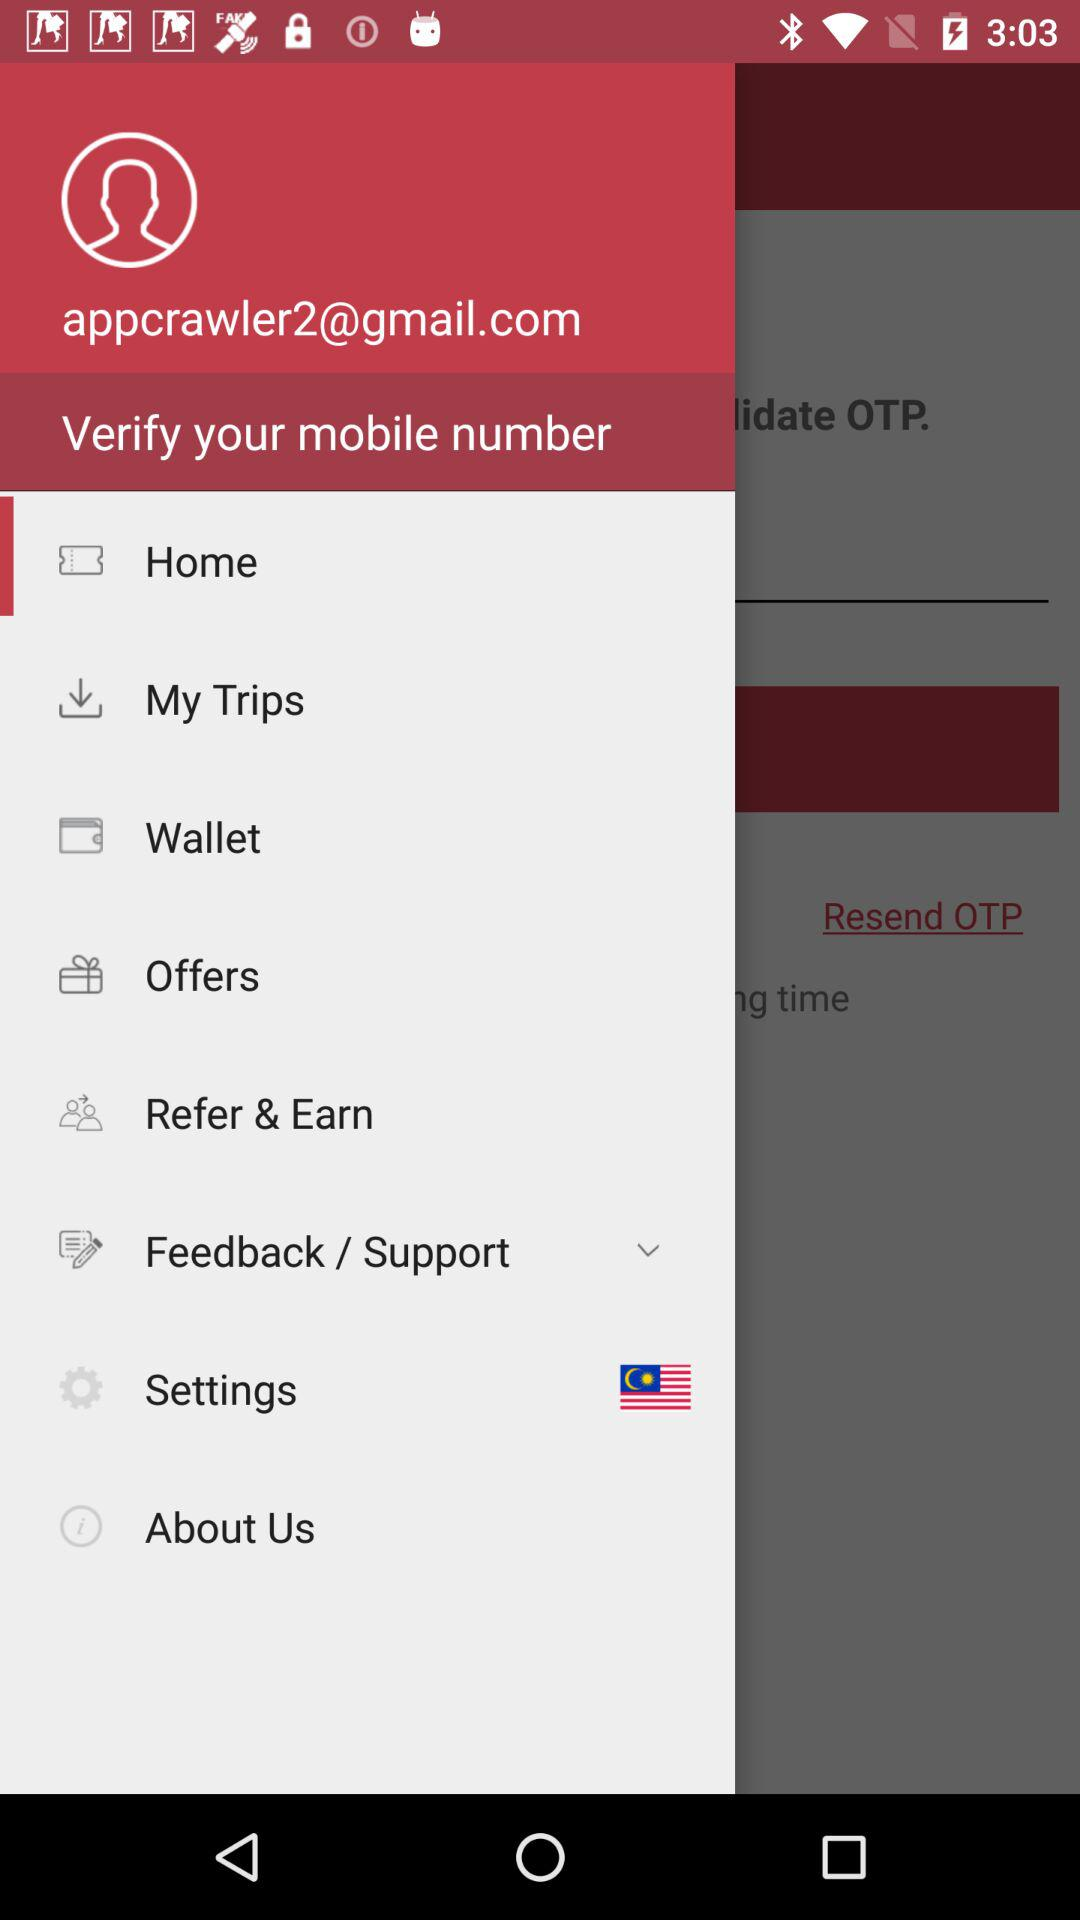What is the email address? The email address is appcrawler2@gmail.com. 